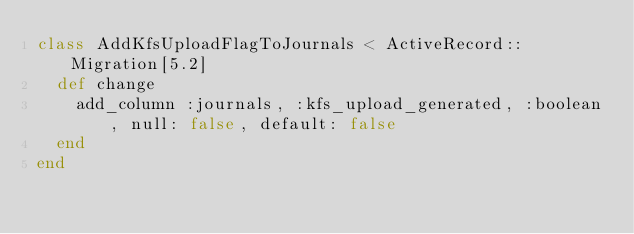Convert code to text. <code><loc_0><loc_0><loc_500><loc_500><_Ruby_>class AddKfsUploadFlagToJournals < ActiveRecord::Migration[5.2]
  def change
    add_column :journals, :kfs_upload_generated, :boolean, null: false, default: false
  end
end
</code> 